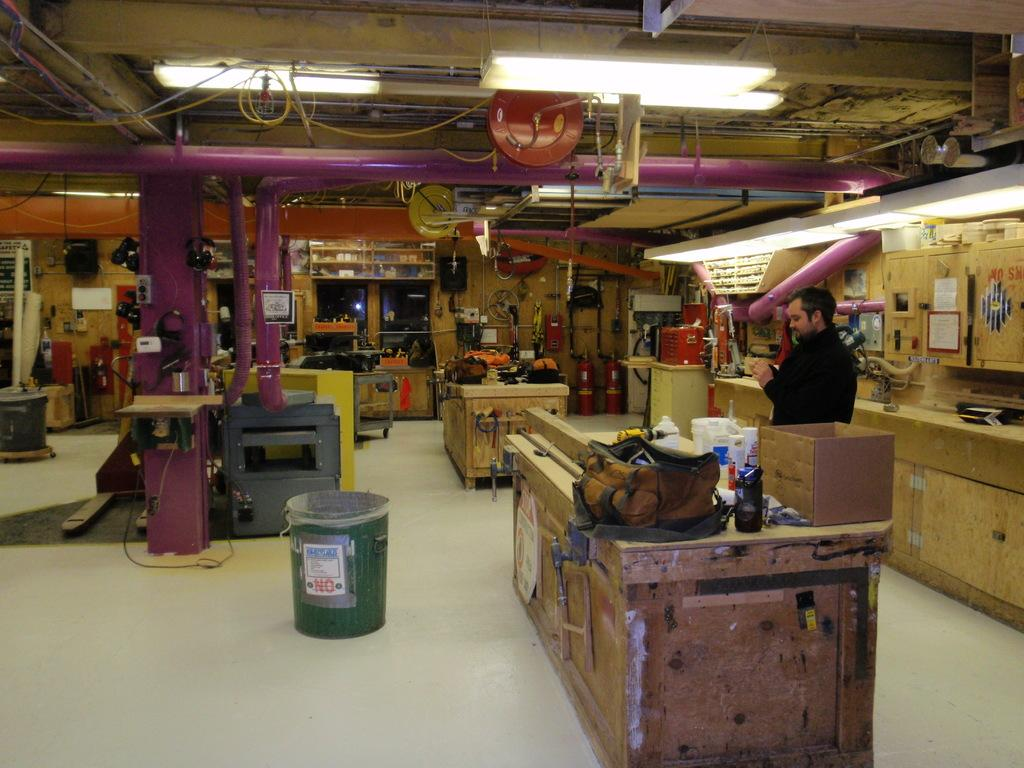What type of furniture is present in the image? There are wooden tables in the image. What color is the bucket visible in the image? The bucket is green in color. Can you describe the person's position in the image? A person is standing on the right side of the image. What else can be seen in the image besides the tables, bucket, and person? There are a few more objects in the image. What type of lighting is present in the background of the image? Ceiling lights are visible in the background of the image. What type of hill can be seen in the background of the image? There is no hill present in the image; it features wooden tables, a green bucket, a person, and ceiling lights. How does the person's feeling affect the image? The person's feelings are not visible or mentioned in the image, so it cannot be determined how they might affect the image. 